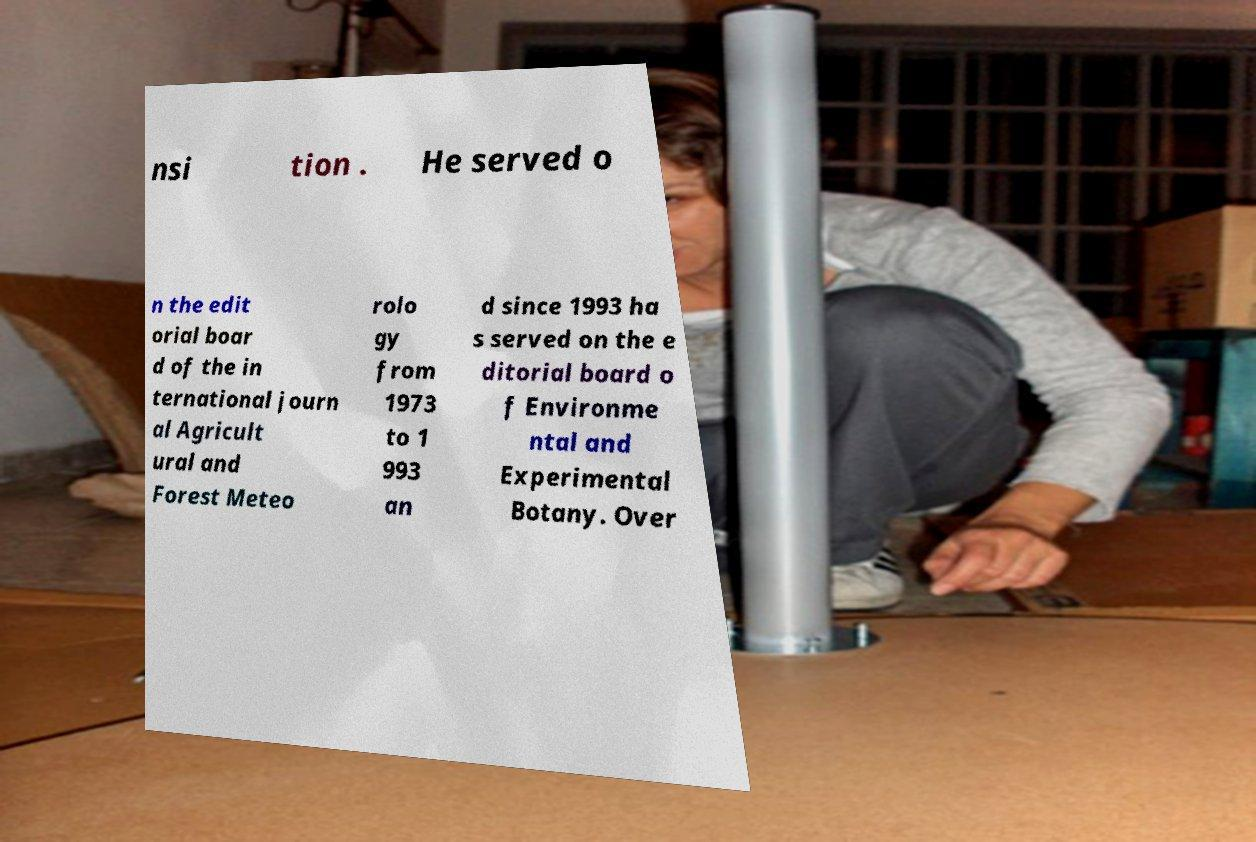Could you extract and type out the text from this image? nsi tion . He served o n the edit orial boar d of the in ternational journ al Agricult ural and Forest Meteo rolo gy from 1973 to 1 993 an d since 1993 ha s served on the e ditorial board o f Environme ntal and Experimental Botany. Over 